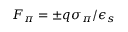Convert formula to latex. <formula><loc_0><loc_0><loc_500><loc_500>F _ { \pi } = \pm q \sigma _ { \pi } / \epsilon _ { s }</formula> 